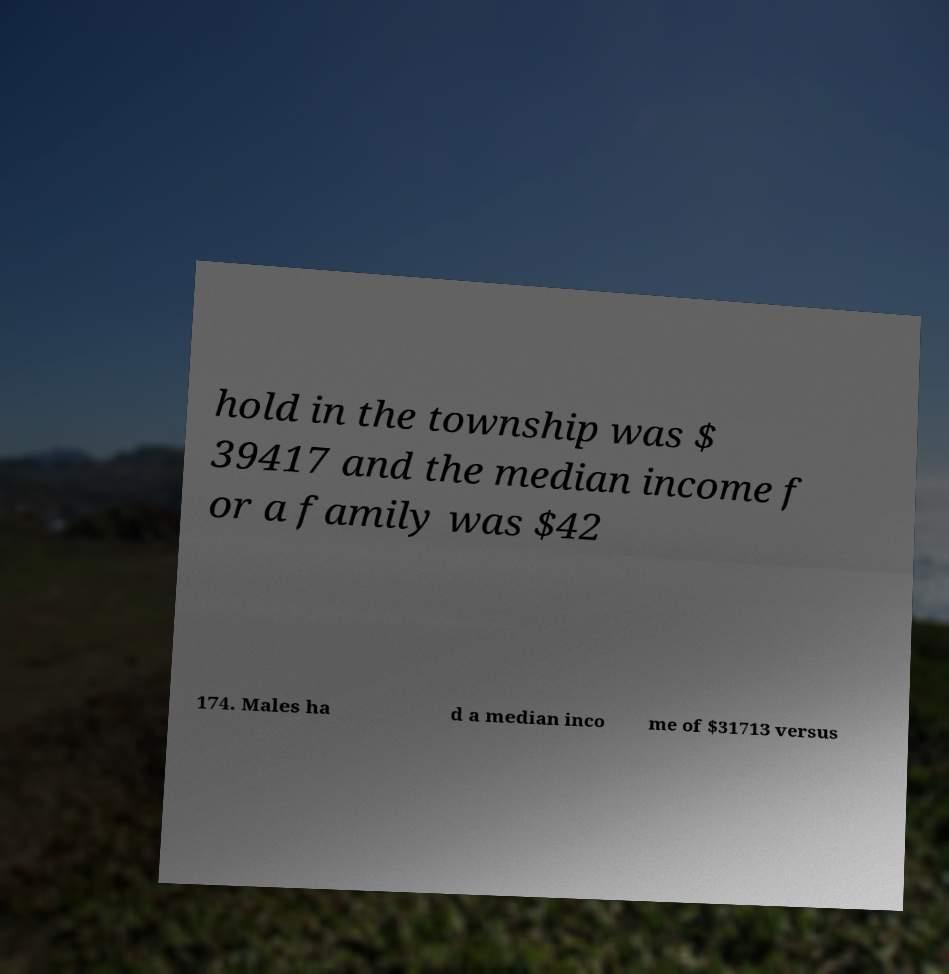Please identify and transcribe the text found in this image. hold in the township was $ 39417 and the median income f or a family was $42 174. Males ha d a median inco me of $31713 versus 